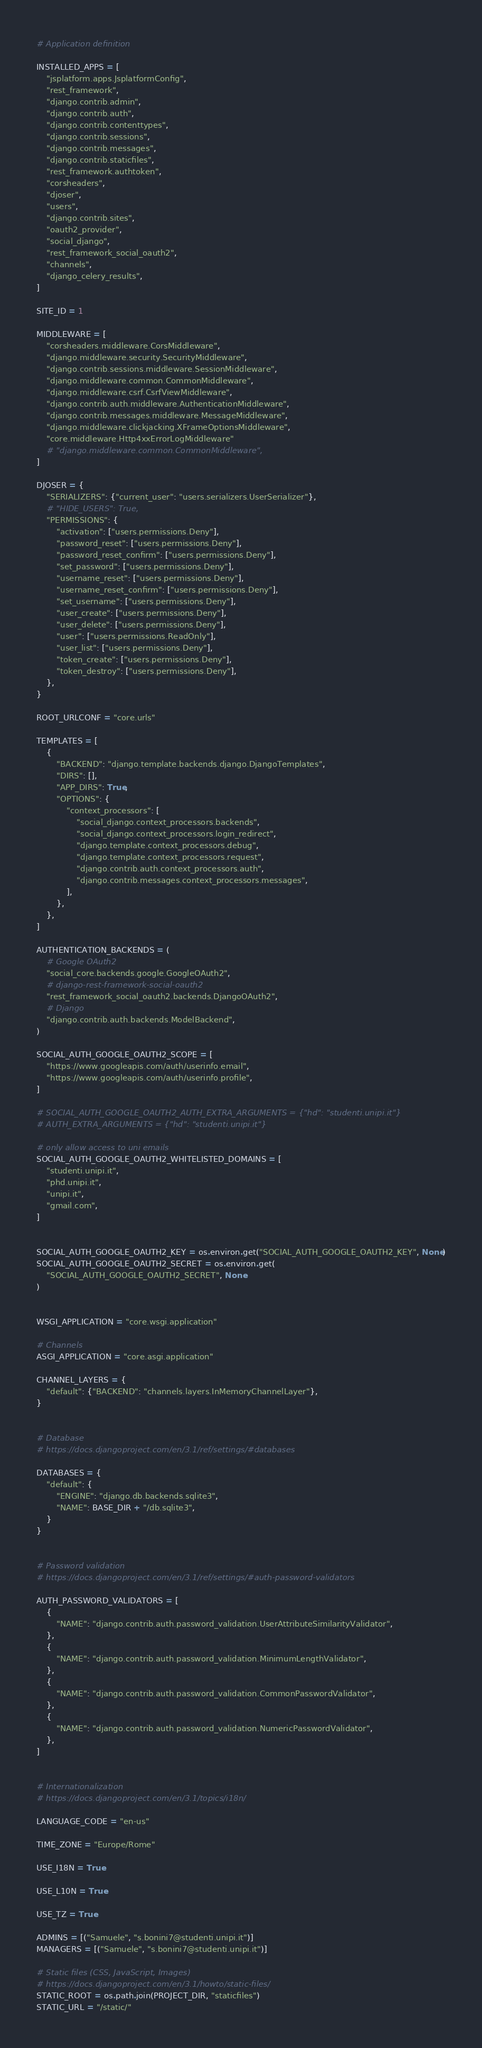Convert code to text. <code><loc_0><loc_0><loc_500><loc_500><_Python_>
# Application definition

INSTALLED_APPS = [
    "jsplatform.apps.JsplatformConfig",
    "rest_framework",
    "django.contrib.admin",
    "django.contrib.auth",
    "django.contrib.contenttypes",
    "django.contrib.sessions",
    "django.contrib.messages",
    "django.contrib.staticfiles",
    "rest_framework.authtoken",
    "corsheaders",
    "djoser",
    "users",
    "django.contrib.sites",
    "oauth2_provider",
    "social_django",
    "rest_framework_social_oauth2",
    "channels",
    "django_celery_results",
]

SITE_ID = 1

MIDDLEWARE = [
    "corsheaders.middleware.CorsMiddleware",
    "django.middleware.security.SecurityMiddleware",
    "django.contrib.sessions.middleware.SessionMiddleware",
    "django.middleware.common.CommonMiddleware",
    "django.middleware.csrf.CsrfViewMiddleware",
    "django.contrib.auth.middleware.AuthenticationMiddleware",
    "django.contrib.messages.middleware.MessageMiddleware",
    "django.middleware.clickjacking.XFrameOptionsMiddleware",
    "core.middleware.Http4xxErrorLogMiddleware"
    # "django.middleware.common.CommonMiddleware",
]

DJOSER = {
    "SERIALIZERS": {"current_user": "users.serializers.UserSerializer"},
    # "HIDE_USERS": True,
    "PERMISSIONS": {
        "activation": ["users.permissions.Deny"],
        "password_reset": ["users.permissions.Deny"],
        "password_reset_confirm": ["users.permissions.Deny"],
        "set_password": ["users.permissions.Deny"],
        "username_reset": ["users.permissions.Deny"],
        "username_reset_confirm": ["users.permissions.Deny"],
        "set_username": ["users.permissions.Deny"],
        "user_create": ["users.permissions.Deny"],
        "user_delete": ["users.permissions.Deny"],
        "user": ["users.permissions.ReadOnly"],
        "user_list": ["users.permissions.Deny"],
        "token_create": ["users.permissions.Deny"],
        "token_destroy": ["users.permissions.Deny"],
    },
}

ROOT_URLCONF = "core.urls"

TEMPLATES = [
    {
        "BACKEND": "django.template.backends.django.DjangoTemplates",
        "DIRS": [],
        "APP_DIRS": True,
        "OPTIONS": {
            "context_processors": [
                "social_django.context_processors.backends",
                "social_django.context_processors.login_redirect",
                "django.template.context_processors.debug",
                "django.template.context_processors.request",
                "django.contrib.auth.context_processors.auth",
                "django.contrib.messages.context_processors.messages",
            ],
        },
    },
]

AUTHENTICATION_BACKENDS = (
    # Google OAuth2
    "social_core.backends.google.GoogleOAuth2",
    # django-rest-framework-social-oauth2
    "rest_framework_social_oauth2.backends.DjangoOAuth2",
    # Django
    "django.contrib.auth.backends.ModelBackend",
)

SOCIAL_AUTH_GOOGLE_OAUTH2_SCOPE = [
    "https://www.googleapis.com/auth/userinfo.email",
    "https://www.googleapis.com/auth/userinfo.profile",
]

# SOCIAL_AUTH_GOOGLE_OAUTH2_AUTH_EXTRA_ARGUMENTS = {"hd": "studenti.unipi.it"}
# AUTH_EXTRA_ARGUMENTS = {"hd": "studenti.unipi.it"}

# only allow access to uni emails
SOCIAL_AUTH_GOOGLE_OAUTH2_WHITELISTED_DOMAINS = [
    "studenti.unipi.it",
    "phd.unipi.it",
    "unipi.it",
    "gmail.com",
]


SOCIAL_AUTH_GOOGLE_OAUTH2_KEY = os.environ.get("SOCIAL_AUTH_GOOGLE_OAUTH2_KEY", None)
SOCIAL_AUTH_GOOGLE_OAUTH2_SECRET = os.environ.get(
    "SOCIAL_AUTH_GOOGLE_OAUTH2_SECRET", None
)


WSGI_APPLICATION = "core.wsgi.application"

# Channels
ASGI_APPLICATION = "core.asgi.application"

CHANNEL_LAYERS = {
    "default": {"BACKEND": "channels.layers.InMemoryChannelLayer"},
}


# Database
# https://docs.djangoproject.com/en/3.1/ref/settings/#databases

DATABASES = {
    "default": {
        "ENGINE": "django.db.backends.sqlite3",
        "NAME": BASE_DIR + "/db.sqlite3",
    }
}


# Password validation
# https://docs.djangoproject.com/en/3.1/ref/settings/#auth-password-validators

AUTH_PASSWORD_VALIDATORS = [
    {
        "NAME": "django.contrib.auth.password_validation.UserAttributeSimilarityValidator",
    },
    {
        "NAME": "django.contrib.auth.password_validation.MinimumLengthValidator",
    },
    {
        "NAME": "django.contrib.auth.password_validation.CommonPasswordValidator",
    },
    {
        "NAME": "django.contrib.auth.password_validation.NumericPasswordValidator",
    },
]


# Internationalization
# https://docs.djangoproject.com/en/3.1/topics/i18n/

LANGUAGE_CODE = "en-us"

TIME_ZONE = "Europe/Rome"

USE_I18N = True

USE_L10N = True

USE_TZ = True

ADMINS = [("Samuele", "s.bonini7@studenti.unipi.it")]
MANAGERS = [("Samuele", "s.bonini7@studenti.unipi.it")]

# Static files (CSS, JavaScript, Images)
# https://docs.djangoproject.com/en/3.1/howto/static-files/
STATIC_ROOT = os.path.join(PROJECT_DIR, "staticfiles")
STATIC_URL = "/static/"
</code> 